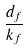Convert formula to latex. <formula><loc_0><loc_0><loc_500><loc_500>\frac { d _ { f } } { k _ { f } }</formula> 